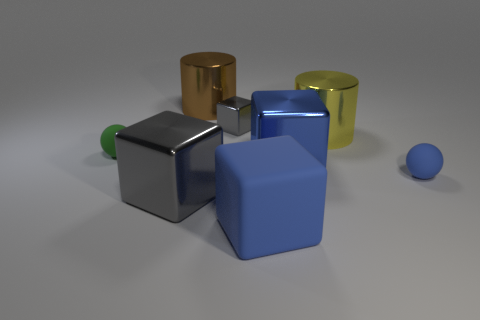Are any of the objects casting shadows and what does this tell us about the lighting? Yes, each object is casting a shadow, which indicates that there is a primary light source in the scene, possibly positioned above and to the side of the objects given the direction of the shadows. 